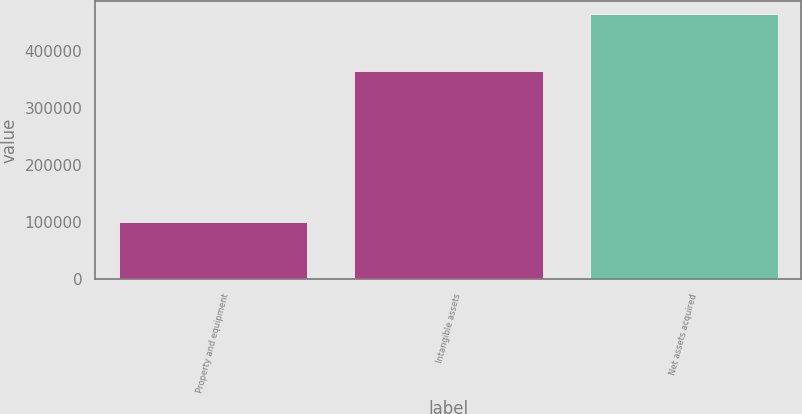<chart> <loc_0><loc_0><loc_500><loc_500><bar_chart><fcel>Property and equipment<fcel>Intangible assets<fcel>Net assets acquired<nl><fcel>99810<fcel>363352<fcel>463162<nl></chart> 